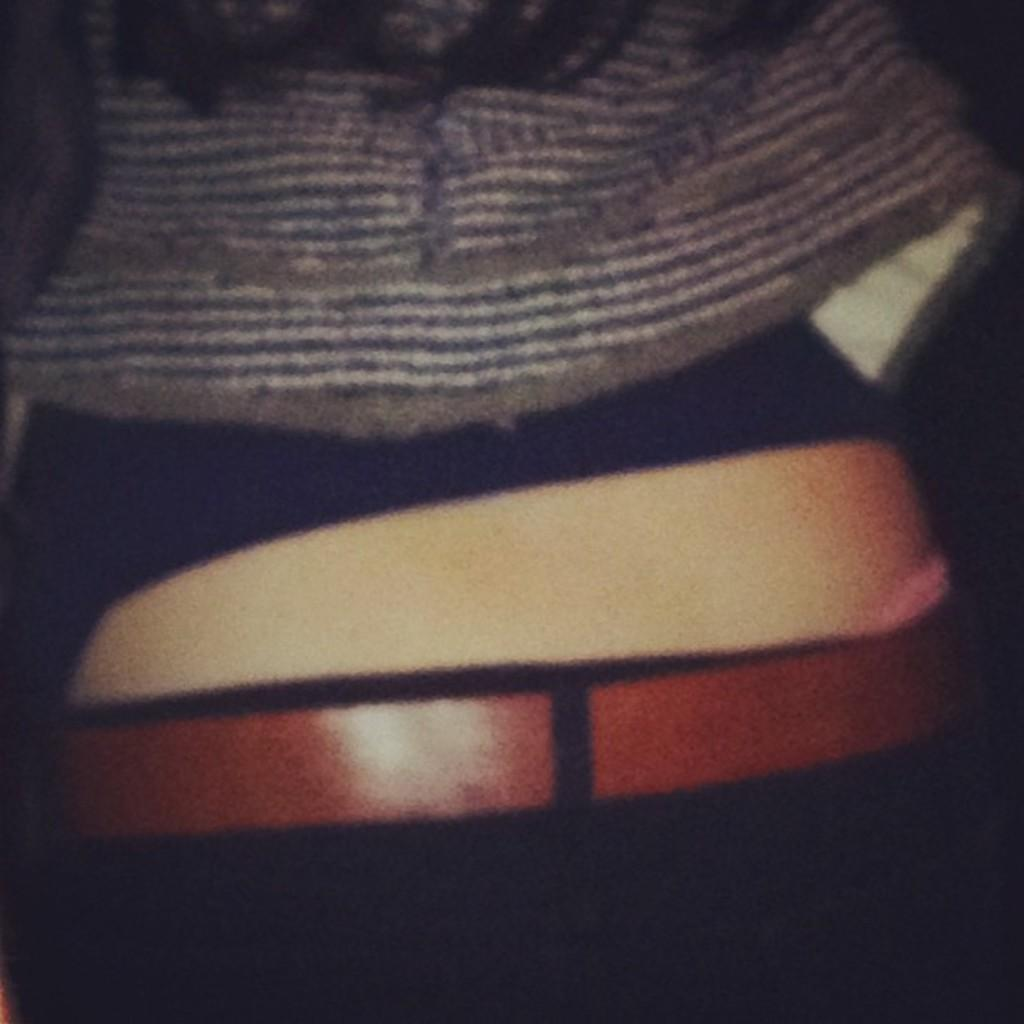What can be seen in the image? There is a person in the image. What is the person wearing around their waist? The person is wearing a belt. What type of clothing is the person wearing on their upper body? The person is wearing a shirt. What type of sign can be seen in the image? There is no sign present in the image. Can you describe the robin that is perched on the person's shoulder in the image? There is no robin present in the image. 